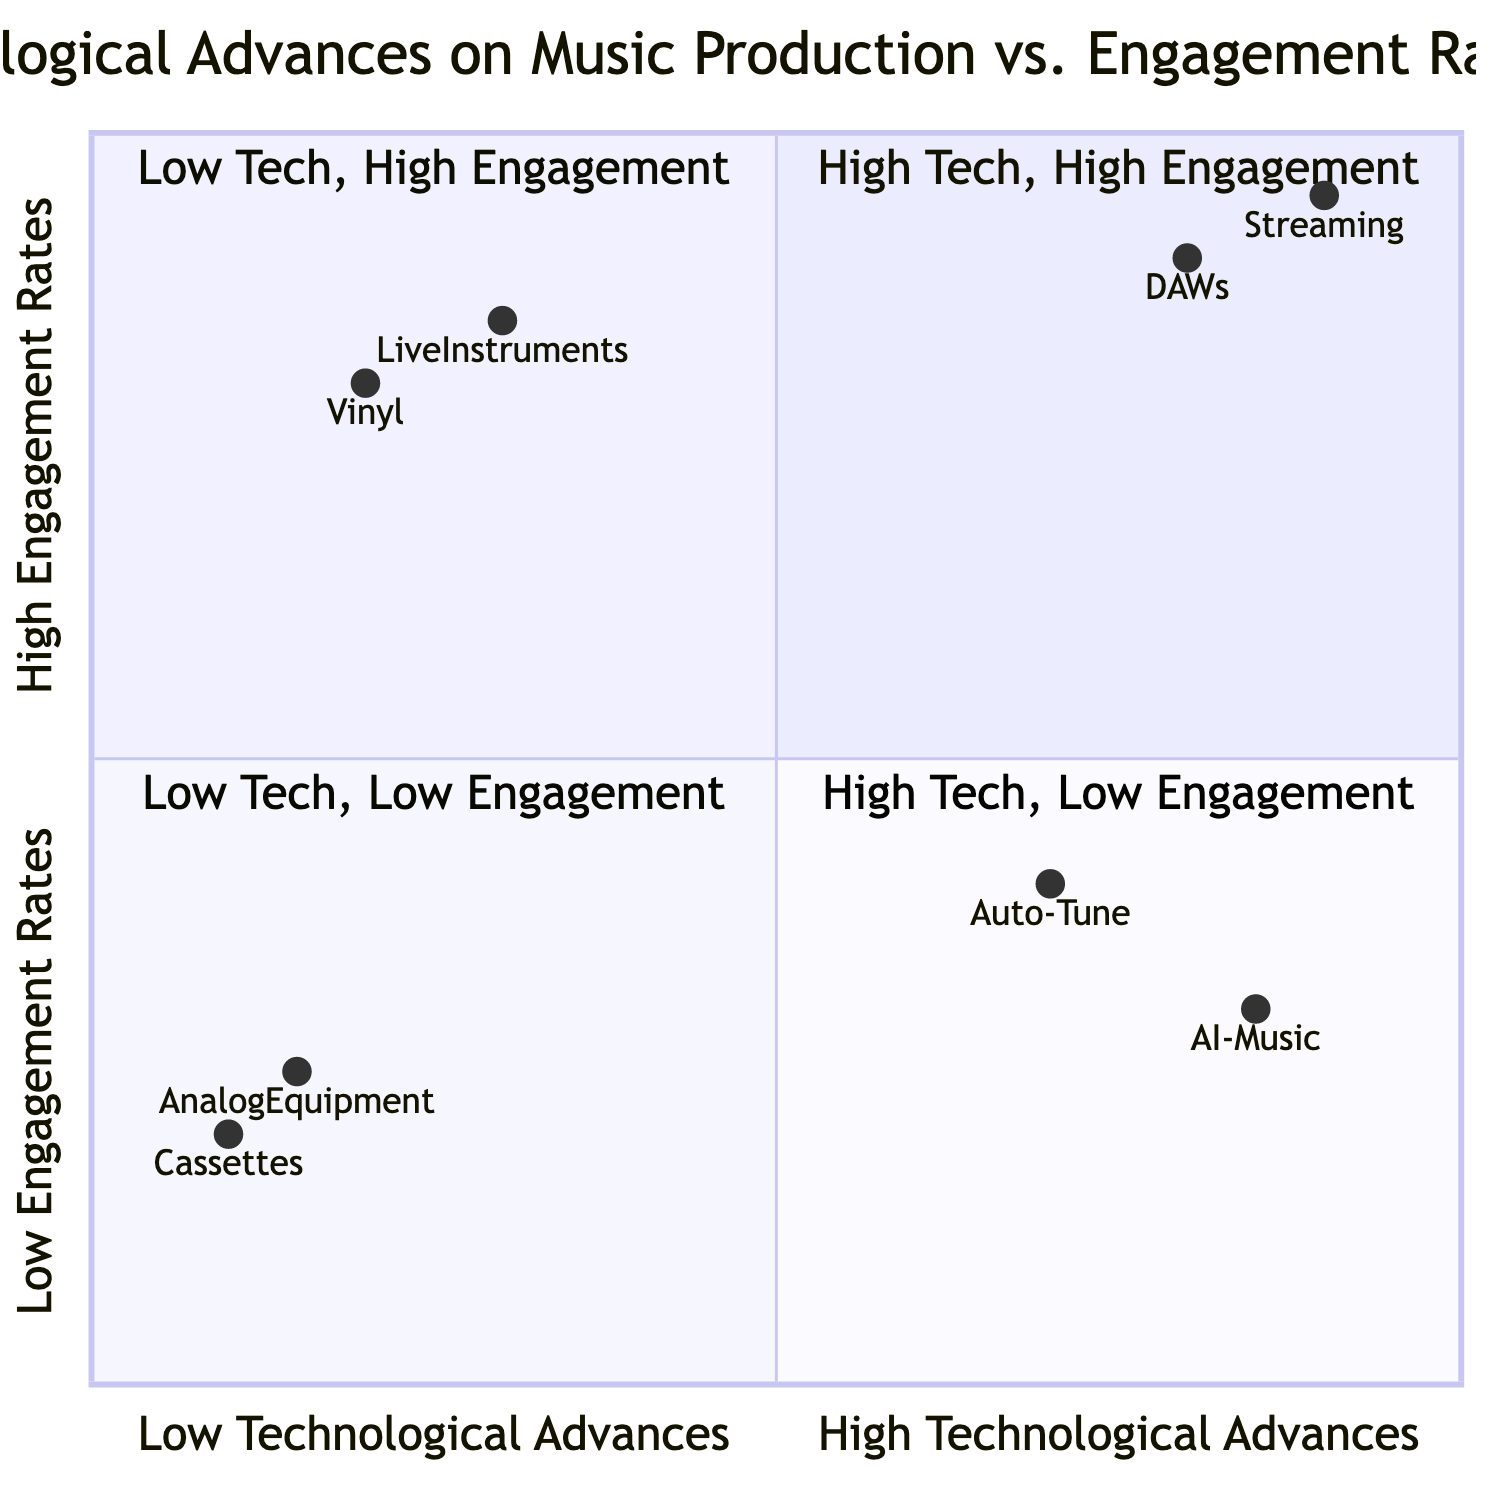What are the two elements in the High Technological Advances, High Engagement Rates quadrant? By examining the quadrant labeled "High Technological Advances, High Engagement Rates," we can identify the two elements listed: "Digital Audio Workstations (DAWs)" and "Streaming Platforms."
Answer: Digital Audio Workstations (DAWs), Streaming Platforms Which quadrant contains AI-Generated Music? AI-Generated Music is located in the quadrant labeled "High Technological Advances, Low Engagement Rates." This can be confidently concluded by looking at the position of AI-Generated Music within the diagram.
Answer: High Technological Advances, Low Engagement Rates What is the engagement rate of Vinyl DJing? The engagement rate for Vinyl DJing, located in the "Low Technological Advances, High Engagement Rates" quadrant, is indicated as 0.8 on the Y-axis of the diagram.
Answer: 0.8 How many elements are in the Low Technological Advances, Low Engagement Rates quadrant? Upon inspecting the quadrant "Low Technological Advances, Low Engagement Rates," we can count the elements provided, which includes "Cassette Tape Demos" and "Analog Equipment Exclusivity." This gives us a total of two elements.
Answer: 2 Which element has the highest engagement rate? Comparing the engagement rates of the elements in all quadrants, we see "Streaming Platforms" in the High Technological Advances, High Engagement Rates quadrant has an engagement rate of 0.95, which is the highest among all listed elements.
Answer: Streaming Platforms What is the relationship between Auto-Tune and engagement rates? Auto-Tune, positioned in the "High Technological Advances, Low Engagement Rates" quadrant, has an engagement rate of 0.4. This indicates that while it may represent high technological advances, it negatively impacts engagement rates.
Answer: Low engagement Which element is closest to the origin of the chart? The closest element to the origin of the quadrant chart, which indicates low technological advances and low engagement rates, is "Cassette Tape Demos," positioned at [0.1, 0.2].
Answer: Cassette Tape Demos What is the technological advance level of Live Instrumentation? Live Instrumentation is found in the "Low Technological Advances, High Engagement Rates" quadrant, indicating a low technological advance level, specifically represented by the X-axis value of 0.3.
Answer: Low Which two elements represent low technological advances but high engagement? The two elements represented in the quadrant for low technological advances and high engagement rates are "Vinyl DJing" and "Live Instrumentation." We can clearly see both listed in the respective quadrant.
Answer: Vinyl DJing, Live Instrumentation 